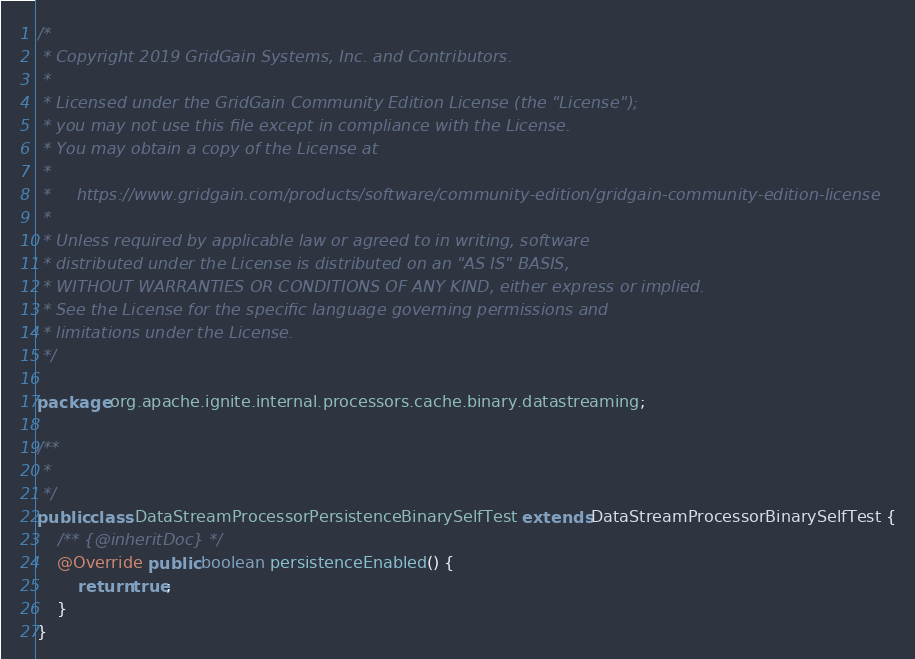Convert code to text. <code><loc_0><loc_0><loc_500><loc_500><_Java_>/*
 * Copyright 2019 GridGain Systems, Inc. and Contributors.
 *
 * Licensed under the GridGain Community Edition License (the "License");
 * you may not use this file except in compliance with the License.
 * You may obtain a copy of the License at
 *
 *     https://www.gridgain.com/products/software/community-edition/gridgain-community-edition-license
 *
 * Unless required by applicable law or agreed to in writing, software
 * distributed under the License is distributed on an "AS IS" BASIS,
 * WITHOUT WARRANTIES OR CONDITIONS OF ANY KIND, either express or implied.
 * See the License for the specific language governing permissions and
 * limitations under the License.
 */

package org.apache.ignite.internal.processors.cache.binary.datastreaming;

/**
 *
 */
public class DataStreamProcessorPersistenceBinarySelfTest extends DataStreamProcessorBinarySelfTest {
    /** {@inheritDoc} */
    @Override public boolean persistenceEnabled() {
        return true;
    }
}
</code> 